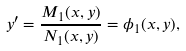<formula> <loc_0><loc_0><loc_500><loc_500>y ^ { \prime } = \frac { M _ { 1 } ( x , y ) } { N _ { 1 } ( x , y ) } = \phi _ { 1 } ( x , y ) ,</formula> 